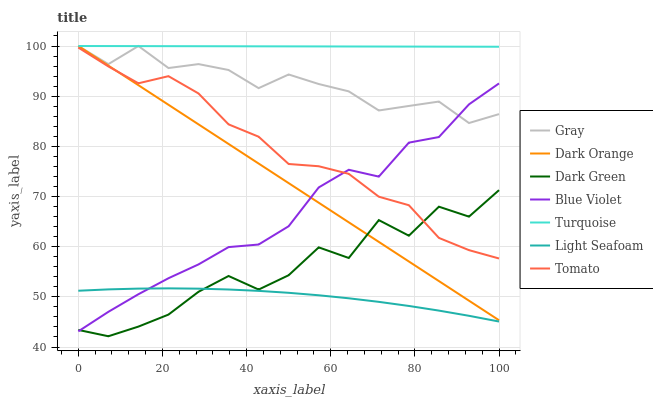Does Gray have the minimum area under the curve?
Answer yes or no. No. Does Gray have the maximum area under the curve?
Answer yes or no. No. Is Gray the smoothest?
Answer yes or no. No. Is Gray the roughest?
Answer yes or no. No. Does Gray have the lowest value?
Answer yes or no. No. Does Light Seafoam have the highest value?
Answer yes or no. No. Is Tomato less than Gray?
Answer yes or no. Yes. Is Tomato greater than Light Seafoam?
Answer yes or no. Yes. Does Tomato intersect Gray?
Answer yes or no. No. 